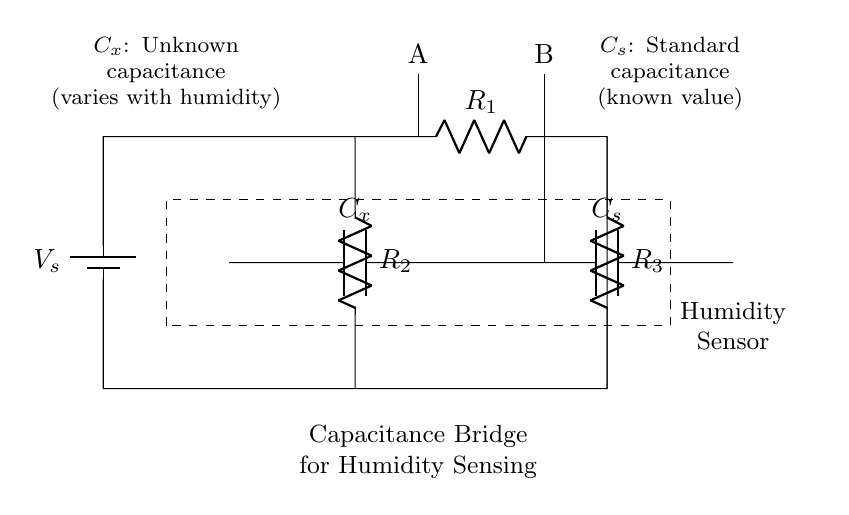What is the standard capacitance value in the circuit? The circuit includes a known capacitance labeled as C_s, but the specific value of C_s is not provided in the diagram. Since C_s is a standard capacitance, it indicates a reference point for measuring C_x. Therefore, without additional information, we cannot specify its numerical value.
Answer: Not specified What component varies with humidity? C_x represents the unknown capacitance that varies with humidity. In a capacitance bridge, C_x is the key element that changes in response to different humidity levels, affecting the overall balance of the circuit.
Answer: C_x Which two points are labeled A and B? Points A and B are labeled at the top of the circuit and indicate the connection points for monitoring voltage across the bridge. The measurements taken at these points help determine whether the bridge is balanced, which indirectly relates to humidity levels.
Answer: A and B How many resistors are present in the circuit? There are three resistors in the circuit: R_1, R_2, and R_3. Counting these components involves identifying each resistor's label in the circuit diagram.
Answer: Three What is the purpose of the dashed rectangle in the circuit? The dashed rectangle encompasses the components associated with the humidity sensing function of the circuit, denoting the area where the measuring process occurs. This highlights that the components within are focused on monitoring humidity through capacitance changes.
Answer: Humidity Sensor What happens when humidity increases? When humidity increases, the capacitance C_x will also increase, which will affect the balance of the bridge circuit. Specifically, an increase in C_x results in a change in the voltage readings at points A and B, indicating higher humidity levels.
Answer: C_x increases What is the function of the battery in this circuit? The battery, labeled as V_s, provides the necessary voltage to the circuit elements, allowing them to function properly. It supplies energy, enabling the capacitors and resistors to operate, which is essential for the measurements taken in the capacitance bridge setup.
Answer: Provides voltage 